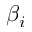Convert formula to latex. <formula><loc_0><loc_0><loc_500><loc_500>\beta _ { i }</formula> 